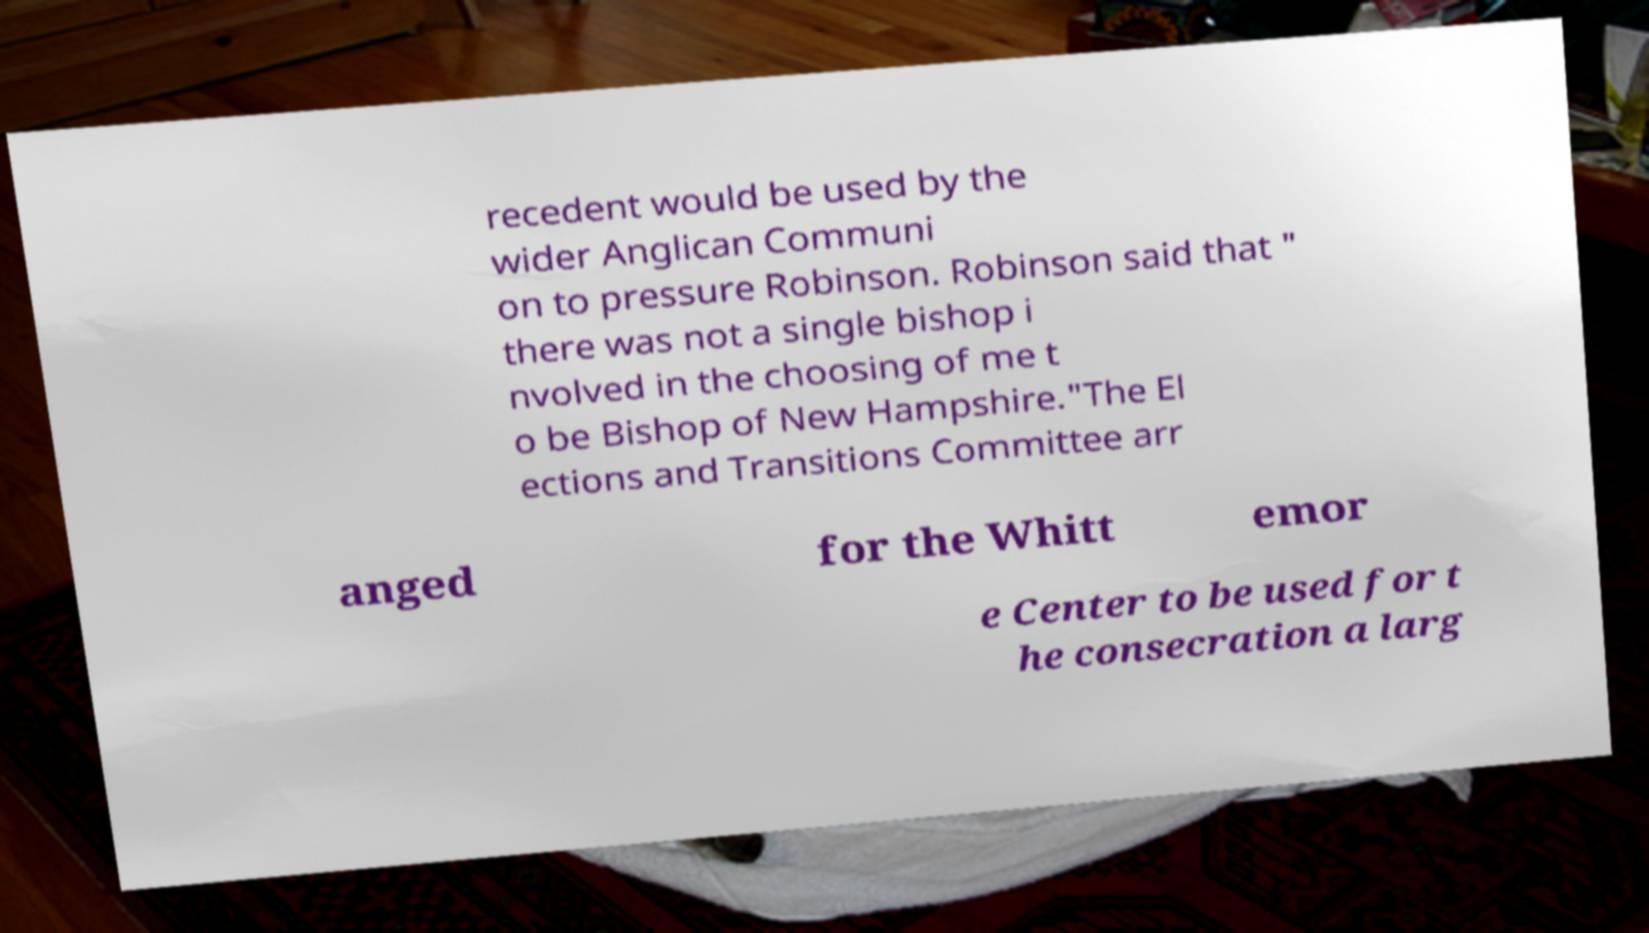There's text embedded in this image that I need extracted. Can you transcribe it verbatim? recedent would be used by the wider Anglican Communi on to pressure Robinson. Robinson said that " there was not a single bishop i nvolved in the choosing of me t o be Bishop of New Hampshire."The El ections and Transitions Committee arr anged for the Whitt emor e Center to be used for t he consecration a larg 